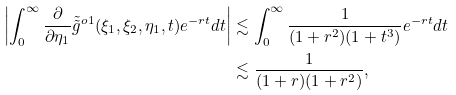Convert formula to latex. <formula><loc_0><loc_0><loc_500><loc_500>\left | \int _ { 0 } ^ { \infty } \frac { \partial } { \partial \eta _ { 1 } } \tilde { \tilde { g } } ^ { o 1 } ( \xi _ { 1 } , \xi _ { 2 } , \eta _ { 1 } , t ) e ^ { - r t } d t \right | & \lesssim \int _ { 0 } ^ { \infty } \frac { 1 } { ( 1 + r ^ { 2 } ) ( 1 + t ^ { 3 } ) } e ^ { - r t } d t \\ & \lesssim \frac { 1 } { ( 1 + r ) ( 1 + r ^ { 2 } ) } ,</formula> 